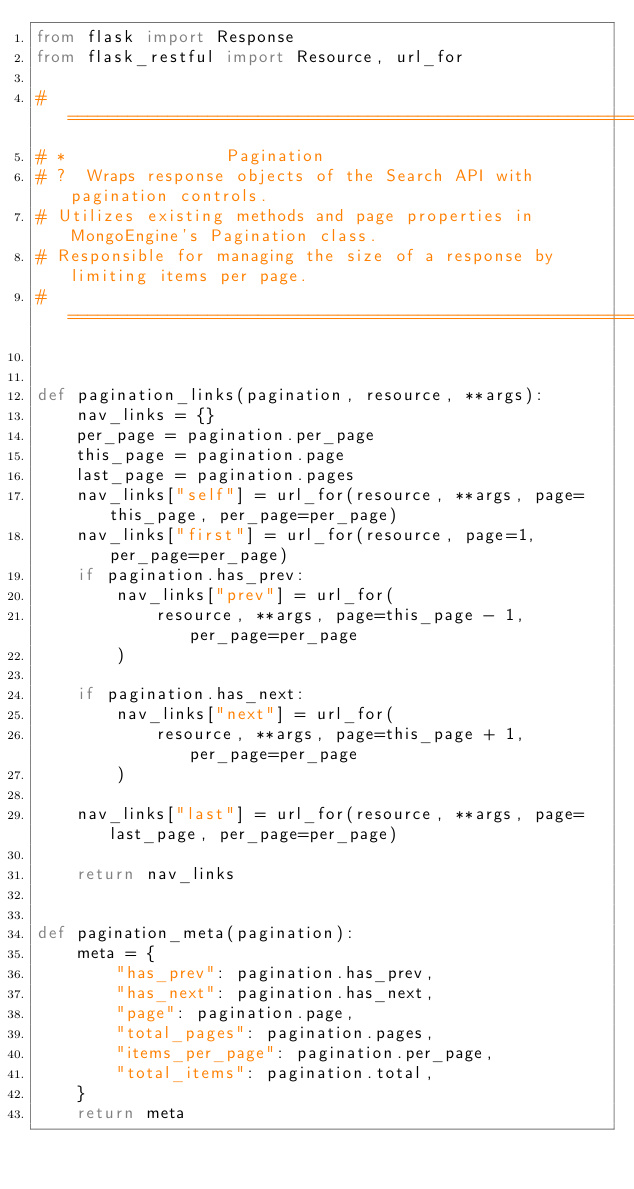Convert code to text. <code><loc_0><loc_0><loc_500><loc_500><_Python_>from flask import Response
from flask_restful import Resource, url_for

# ===========================================================================
# *                Pagination
# ?  Wraps response objects of the Search API with pagination controls.
# Utilizes existing methods and page properties in MongoEngine's Pagination class.
# Responsible for managing the size of a response by limiting items per page.
# ===========================================================================


def pagination_links(pagination, resource, **args):
    nav_links = {}
    per_page = pagination.per_page
    this_page = pagination.page
    last_page = pagination.pages
    nav_links["self"] = url_for(resource, **args, page=this_page, per_page=per_page)
    nav_links["first"] = url_for(resource, page=1, per_page=per_page)
    if pagination.has_prev:
        nav_links["prev"] = url_for(
            resource, **args, page=this_page - 1, per_page=per_page
        )

    if pagination.has_next:
        nav_links["next"] = url_for(
            resource, **args, page=this_page + 1, per_page=per_page
        )

    nav_links["last"] = url_for(resource, **args, page=last_page, per_page=per_page)

    return nav_links


def pagination_meta(pagination):
    meta = {
        "has_prev": pagination.has_prev,
        "has_next": pagination.has_next,
        "page": pagination.page,
        "total_pages": pagination.pages,
        "items_per_page": pagination.per_page,
        "total_items": pagination.total,
    }
    return meta
</code> 